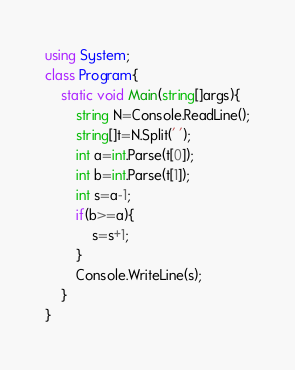Convert code to text. <code><loc_0><loc_0><loc_500><loc_500><_C#_>using System;
class Program{
    static void Main(string[]args){
        string N=Console.ReadLine();
        string[]t=N.Split(' ');
        int a=int.Parse(t[0]);
        int b=int.Parse(t[1]);
        int s=a-1;
        if(b>=a){
            s=s+1;
        }
        Console.WriteLine(s);
    }
}</code> 